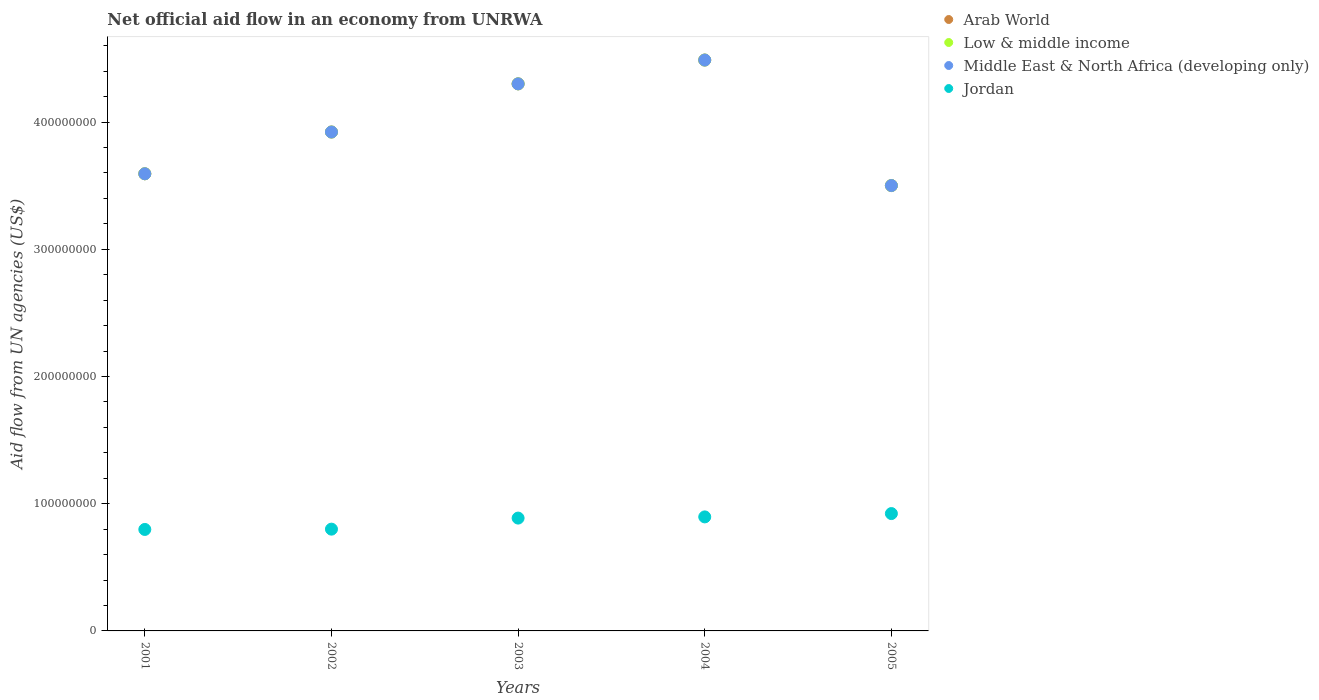What is the net official aid flow in Low & middle income in 2005?
Offer a terse response. 3.50e+08. Across all years, what is the maximum net official aid flow in Arab World?
Offer a terse response. 4.49e+08. Across all years, what is the minimum net official aid flow in Low & middle income?
Keep it short and to the point. 3.50e+08. In which year was the net official aid flow in Middle East & North Africa (developing only) minimum?
Ensure brevity in your answer.  2005. What is the total net official aid flow in Jordan in the graph?
Keep it short and to the point. 4.30e+08. What is the difference between the net official aid flow in Middle East & North Africa (developing only) in 2004 and the net official aid flow in Jordan in 2003?
Your response must be concise. 3.60e+08. What is the average net official aid flow in Low & middle income per year?
Keep it short and to the point. 3.96e+08. In how many years, is the net official aid flow in Low & middle income greater than 440000000 US$?
Ensure brevity in your answer.  1. What is the ratio of the net official aid flow in Arab World in 2001 to that in 2005?
Offer a very short reply. 1.03. What is the difference between the highest and the second highest net official aid flow in Middle East & North Africa (developing only)?
Offer a terse response. 1.87e+07. What is the difference between the highest and the lowest net official aid flow in Jordan?
Ensure brevity in your answer.  1.25e+07. In how many years, is the net official aid flow in Middle East & North Africa (developing only) greater than the average net official aid flow in Middle East & North Africa (developing only) taken over all years?
Your answer should be very brief. 2. Does the net official aid flow in Middle East & North Africa (developing only) monotonically increase over the years?
Your answer should be very brief. No. How many years are there in the graph?
Offer a terse response. 5. What is the difference between two consecutive major ticks on the Y-axis?
Ensure brevity in your answer.  1.00e+08. Does the graph contain grids?
Provide a short and direct response. No. How many legend labels are there?
Ensure brevity in your answer.  4. How are the legend labels stacked?
Your answer should be very brief. Vertical. What is the title of the graph?
Keep it short and to the point. Net official aid flow in an economy from UNRWA. What is the label or title of the Y-axis?
Provide a short and direct response. Aid flow from UN agencies (US$). What is the Aid flow from UN agencies (US$) of Arab World in 2001?
Your answer should be very brief. 3.59e+08. What is the Aid flow from UN agencies (US$) of Low & middle income in 2001?
Give a very brief answer. 3.59e+08. What is the Aid flow from UN agencies (US$) in Middle East & North Africa (developing only) in 2001?
Give a very brief answer. 3.59e+08. What is the Aid flow from UN agencies (US$) in Jordan in 2001?
Ensure brevity in your answer.  7.98e+07. What is the Aid flow from UN agencies (US$) in Arab World in 2002?
Provide a succinct answer. 3.92e+08. What is the Aid flow from UN agencies (US$) in Low & middle income in 2002?
Ensure brevity in your answer.  3.92e+08. What is the Aid flow from UN agencies (US$) in Middle East & North Africa (developing only) in 2002?
Your response must be concise. 3.92e+08. What is the Aid flow from UN agencies (US$) of Jordan in 2002?
Offer a very short reply. 8.00e+07. What is the Aid flow from UN agencies (US$) of Arab World in 2003?
Make the answer very short. 4.30e+08. What is the Aid flow from UN agencies (US$) of Low & middle income in 2003?
Ensure brevity in your answer.  4.30e+08. What is the Aid flow from UN agencies (US$) of Middle East & North Africa (developing only) in 2003?
Make the answer very short. 4.30e+08. What is the Aid flow from UN agencies (US$) in Jordan in 2003?
Your response must be concise. 8.87e+07. What is the Aid flow from UN agencies (US$) in Arab World in 2004?
Your answer should be compact. 4.49e+08. What is the Aid flow from UN agencies (US$) in Low & middle income in 2004?
Offer a terse response. 4.49e+08. What is the Aid flow from UN agencies (US$) in Middle East & North Africa (developing only) in 2004?
Provide a short and direct response. 4.49e+08. What is the Aid flow from UN agencies (US$) in Jordan in 2004?
Offer a terse response. 8.96e+07. What is the Aid flow from UN agencies (US$) in Arab World in 2005?
Your answer should be very brief. 3.50e+08. What is the Aid flow from UN agencies (US$) of Low & middle income in 2005?
Offer a terse response. 3.50e+08. What is the Aid flow from UN agencies (US$) of Middle East & North Africa (developing only) in 2005?
Provide a succinct answer. 3.50e+08. What is the Aid flow from UN agencies (US$) in Jordan in 2005?
Provide a short and direct response. 9.22e+07. Across all years, what is the maximum Aid flow from UN agencies (US$) of Arab World?
Ensure brevity in your answer.  4.49e+08. Across all years, what is the maximum Aid flow from UN agencies (US$) of Low & middle income?
Ensure brevity in your answer.  4.49e+08. Across all years, what is the maximum Aid flow from UN agencies (US$) of Middle East & North Africa (developing only)?
Make the answer very short. 4.49e+08. Across all years, what is the maximum Aid flow from UN agencies (US$) of Jordan?
Offer a terse response. 9.22e+07. Across all years, what is the minimum Aid flow from UN agencies (US$) in Arab World?
Your response must be concise. 3.50e+08. Across all years, what is the minimum Aid flow from UN agencies (US$) of Low & middle income?
Provide a short and direct response. 3.50e+08. Across all years, what is the minimum Aid flow from UN agencies (US$) of Middle East & North Africa (developing only)?
Provide a short and direct response. 3.50e+08. Across all years, what is the minimum Aid flow from UN agencies (US$) in Jordan?
Offer a very short reply. 7.98e+07. What is the total Aid flow from UN agencies (US$) in Arab World in the graph?
Offer a very short reply. 1.98e+09. What is the total Aid flow from UN agencies (US$) in Low & middle income in the graph?
Provide a succinct answer. 1.98e+09. What is the total Aid flow from UN agencies (US$) in Middle East & North Africa (developing only) in the graph?
Your answer should be compact. 1.98e+09. What is the total Aid flow from UN agencies (US$) in Jordan in the graph?
Offer a very short reply. 4.30e+08. What is the difference between the Aid flow from UN agencies (US$) of Arab World in 2001 and that in 2002?
Your answer should be compact. -3.28e+07. What is the difference between the Aid flow from UN agencies (US$) in Low & middle income in 2001 and that in 2002?
Make the answer very short. -3.28e+07. What is the difference between the Aid flow from UN agencies (US$) of Middle East & North Africa (developing only) in 2001 and that in 2002?
Your answer should be compact. -3.28e+07. What is the difference between the Aid flow from UN agencies (US$) in Jordan in 2001 and that in 2002?
Give a very brief answer. -2.40e+05. What is the difference between the Aid flow from UN agencies (US$) in Arab World in 2001 and that in 2003?
Offer a very short reply. -7.07e+07. What is the difference between the Aid flow from UN agencies (US$) in Low & middle income in 2001 and that in 2003?
Your response must be concise. -7.07e+07. What is the difference between the Aid flow from UN agencies (US$) of Middle East & North Africa (developing only) in 2001 and that in 2003?
Offer a terse response. -7.07e+07. What is the difference between the Aid flow from UN agencies (US$) of Jordan in 2001 and that in 2003?
Your response must be concise. -8.93e+06. What is the difference between the Aid flow from UN agencies (US$) in Arab World in 2001 and that in 2004?
Offer a very short reply. -8.94e+07. What is the difference between the Aid flow from UN agencies (US$) of Low & middle income in 2001 and that in 2004?
Provide a short and direct response. -8.94e+07. What is the difference between the Aid flow from UN agencies (US$) in Middle East & North Africa (developing only) in 2001 and that in 2004?
Provide a succinct answer. -8.94e+07. What is the difference between the Aid flow from UN agencies (US$) of Jordan in 2001 and that in 2004?
Your answer should be compact. -9.87e+06. What is the difference between the Aid flow from UN agencies (US$) of Arab World in 2001 and that in 2005?
Provide a short and direct response. 9.26e+06. What is the difference between the Aid flow from UN agencies (US$) of Low & middle income in 2001 and that in 2005?
Offer a very short reply. 9.26e+06. What is the difference between the Aid flow from UN agencies (US$) of Middle East & North Africa (developing only) in 2001 and that in 2005?
Your answer should be very brief. 9.26e+06. What is the difference between the Aid flow from UN agencies (US$) of Jordan in 2001 and that in 2005?
Your answer should be compact. -1.25e+07. What is the difference between the Aid flow from UN agencies (US$) of Arab World in 2002 and that in 2003?
Ensure brevity in your answer.  -3.79e+07. What is the difference between the Aid flow from UN agencies (US$) of Low & middle income in 2002 and that in 2003?
Provide a succinct answer. -3.79e+07. What is the difference between the Aid flow from UN agencies (US$) in Middle East & North Africa (developing only) in 2002 and that in 2003?
Your answer should be very brief. -3.79e+07. What is the difference between the Aid flow from UN agencies (US$) in Jordan in 2002 and that in 2003?
Your response must be concise. -8.69e+06. What is the difference between the Aid flow from UN agencies (US$) of Arab World in 2002 and that in 2004?
Keep it short and to the point. -5.66e+07. What is the difference between the Aid flow from UN agencies (US$) of Low & middle income in 2002 and that in 2004?
Offer a terse response. -5.66e+07. What is the difference between the Aid flow from UN agencies (US$) in Middle East & North Africa (developing only) in 2002 and that in 2004?
Provide a succinct answer. -5.66e+07. What is the difference between the Aid flow from UN agencies (US$) in Jordan in 2002 and that in 2004?
Your answer should be very brief. -9.63e+06. What is the difference between the Aid flow from UN agencies (US$) in Arab World in 2002 and that in 2005?
Keep it short and to the point. 4.21e+07. What is the difference between the Aid flow from UN agencies (US$) in Low & middle income in 2002 and that in 2005?
Ensure brevity in your answer.  4.21e+07. What is the difference between the Aid flow from UN agencies (US$) of Middle East & North Africa (developing only) in 2002 and that in 2005?
Your answer should be very brief. 4.21e+07. What is the difference between the Aid flow from UN agencies (US$) in Jordan in 2002 and that in 2005?
Your answer should be compact. -1.22e+07. What is the difference between the Aid flow from UN agencies (US$) in Arab World in 2003 and that in 2004?
Provide a succinct answer. -1.87e+07. What is the difference between the Aid flow from UN agencies (US$) in Low & middle income in 2003 and that in 2004?
Make the answer very short. -1.87e+07. What is the difference between the Aid flow from UN agencies (US$) in Middle East & North Africa (developing only) in 2003 and that in 2004?
Ensure brevity in your answer.  -1.87e+07. What is the difference between the Aid flow from UN agencies (US$) of Jordan in 2003 and that in 2004?
Keep it short and to the point. -9.40e+05. What is the difference between the Aid flow from UN agencies (US$) of Arab World in 2003 and that in 2005?
Ensure brevity in your answer.  8.00e+07. What is the difference between the Aid flow from UN agencies (US$) in Low & middle income in 2003 and that in 2005?
Offer a terse response. 8.00e+07. What is the difference between the Aid flow from UN agencies (US$) in Middle East & North Africa (developing only) in 2003 and that in 2005?
Your answer should be compact. 8.00e+07. What is the difference between the Aid flow from UN agencies (US$) of Jordan in 2003 and that in 2005?
Give a very brief answer. -3.55e+06. What is the difference between the Aid flow from UN agencies (US$) in Arab World in 2004 and that in 2005?
Keep it short and to the point. 9.87e+07. What is the difference between the Aid flow from UN agencies (US$) in Low & middle income in 2004 and that in 2005?
Your answer should be compact. 9.87e+07. What is the difference between the Aid flow from UN agencies (US$) in Middle East & North Africa (developing only) in 2004 and that in 2005?
Offer a terse response. 9.87e+07. What is the difference between the Aid flow from UN agencies (US$) of Jordan in 2004 and that in 2005?
Your answer should be very brief. -2.61e+06. What is the difference between the Aid flow from UN agencies (US$) of Arab World in 2001 and the Aid flow from UN agencies (US$) of Low & middle income in 2002?
Your response must be concise. -3.28e+07. What is the difference between the Aid flow from UN agencies (US$) of Arab World in 2001 and the Aid flow from UN agencies (US$) of Middle East & North Africa (developing only) in 2002?
Your answer should be very brief. -3.28e+07. What is the difference between the Aid flow from UN agencies (US$) in Arab World in 2001 and the Aid flow from UN agencies (US$) in Jordan in 2002?
Ensure brevity in your answer.  2.79e+08. What is the difference between the Aid flow from UN agencies (US$) in Low & middle income in 2001 and the Aid flow from UN agencies (US$) in Middle East & North Africa (developing only) in 2002?
Give a very brief answer. -3.28e+07. What is the difference between the Aid flow from UN agencies (US$) of Low & middle income in 2001 and the Aid flow from UN agencies (US$) of Jordan in 2002?
Keep it short and to the point. 2.79e+08. What is the difference between the Aid flow from UN agencies (US$) of Middle East & North Africa (developing only) in 2001 and the Aid flow from UN agencies (US$) of Jordan in 2002?
Your answer should be compact. 2.79e+08. What is the difference between the Aid flow from UN agencies (US$) in Arab World in 2001 and the Aid flow from UN agencies (US$) in Low & middle income in 2003?
Provide a short and direct response. -7.07e+07. What is the difference between the Aid flow from UN agencies (US$) of Arab World in 2001 and the Aid flow from UN agencies (US$) of Middle East & North Africa (developing only) in 2003?
Make the answer very short. -7.07e+07. What is the difference between the Aid flow from UN agencies (US$) of Arab World in 2001 and the Aid flow from UN agencies (US$) of Jordan in 2003?
Make the answer very short. 2.71e+08. What is the difference between the Aid flow from UN agencies (US$) of Low & middle income in 2001 and the Aid flow from UN agencies (US$) of Middle East & North Africa (developing only) in 2003?
Give a very brief answer. -7.07e+07. What is the difference between the Aid flow from UN agencies (US$) in Low & middle income in 2001 and the Aid flow from UN agencies (US$) in Jordan in 2003?
Provide a short and direct response. 2.71e+08. What is the difference between the Aid flow from UN agencies (US$) in Middle East & North Africa (developing only) in 2001 and the Aid flow from UN agencies (US$) in Jordan in 2003?
Your answer should be very brief. 2.71e+08. What is the difference between the Aid flow from UN agencies (US$) in Arab World in 2001 and the Aid flow from UN agencies (US$) in Low & middle income in 2004?
Your answer should be compact. -8.94e+07. What is the difference between the Aid flow from UN agencies (US$) in Arab World in 2001 and the Aid flow from UN agencies (US$) in Middle East & North Africa (developing only) in 2004?
Provide a succinct answer. -8.94e+07. What is the difference between the Aid flow from UN agencies (US$) of Arab World in 2001 and the Aid flow from UN agencies (US$) of Jordan in 2004?
Make the answer very short. 2.70e+08. What is the difference between the Aid flow from UN agencies (US$) of Low & middle income in 2001 and the Aid flow from UN agencies (US$) of Middle East & North Africa (developing only) in 2004?
Offer a terse response. -8.94e+07. What is the difference between the Aid flow from UN agencies (US$) of Low & middle income in 2001 and the Aid flow from UN agencies (US$) of Jordan in 2004?
Your response must be concise. 2.70e+08. What is the difference between the Aid flow from UN agencies (US$) of Middle East & North Africa (developing only) in 2001 and the Aid flow from UN agencies (US$) of Jordan in 2004?
Give a very brief answer. 2.70e+08. What is the difference between the Aid flow from UN agencies (US$) in Arab World in 2001 and the Aid flow from UN agencies (US$) in Low & middle income in 2005?
Keep it short and to the point. 9.26e+06. What is the difference between the Aid flow from UN agencies (US$) of Arab World in 2001 and the Aid flow from UN agencies (US$) of Middle East & North Africa (developing only) in 2005?
Your response must be concise. 9.26e+06. What is the difference between the Aid flow from UN agencies (US$) of Arab World in 2001 and the Aid flow from UN agencies (US$) of Jordan in 2005?
Ensure brevity in your answer.  2.67e+08. What is the difference between the Aid flow from UN agencies (US$) of Low & middle income in 2001 and the Aid flow from UN agencies (US$) of Middle East & North Africa (developing only) in 2005?
Provide a short and direct response. 9.26e+06. What is the difference between the Aid flow from UN agencies (US$) in Low & middle income in 2001 and the Aid flow from UN agencies (US$) in Jordan in 2005?
Give a very brief answer. 2.67e+08. What is the difference between the Aid flow from UN agencies (US$) in Middle East & North Africa (developing only) in 2001 and the Aid flow from UN agencies (US$) in Jordan in 2005?
Your response must be concise. 2.67e+08. What is the difference between the Aid flow from UN agencies (US$) in Arab World in 2002 and the Aid flow from UN agencies (US$) in Low & middle income in 2003?
Give a very brief answer. -3.79e+07. What is the difference between the Aid flow from UN agencies (US$) of Arab World in 2002 and the Aid flow from UN agencies (US$) of Middle East & North Africa (developing only) in 2003?
Your answer should be very brief. -3.79e+07. What is the difference between the Aid flow from UN agencies (US$) of Arab World in 2002 and the Aid flow from UN agencies (US$) of Jordan in 2003?
Give a very brief answer. 3.04e+08. What is the difference between the Aid flow from UN agencies (US$) of Low & middle income in 2002 and the Aid flow from UN agencies (US$) of Middle East & North Africa (developing only) in 2003?
Provide a short and direct response. -3.79e+07. What is the difference between the Aid flow from UN agencies (US$) in Low & middle income in 2002 and the Aid flow from UN agencies (US$) in Jordan in 2003?
Offer a very short reply. 3.04e+08. What is the difference between the Aid flow from UN agencies (US$) in Middle East & North Africa (developing only) in 2002 and the Aid flow from UN agencies (US$) in Jordan in 2003?
Offer a terse response. 3.04e+08. What is the difference between the Aid flow from UN agencies (US$) in Arab World in 2002 and the Aid flow from UN agencies (US$) in Low & middle income in 2004?
Make the answer very short. -5.66e+07. What is the difference between the Aid flow from UN agencies (US$) in Arab World in 2002 and the Aid flow from UN agencies (US$) in Middle East & North Africa (developing only) in 2004?
Offer a very short reply. -5.66e+07. What is the difference between the Aid flow from UN agencies (US$) of Arab World in 2002 and the Aid flow from UN agencies (US$) of Jordan in 2004?
Provide a succinct answer. 3.03e+08. What is the difference between the Aid flow from UN agencies (US$) in Low & middle income in 2002 and the Aid flow from UN agencies (US$) in Middle East & North Africa (developing only) in 2004?
Your response must be concise. -5.66e+07. What is the difference between the Aid flow from UN agencies (US$) in Low & middle income in 2002 and the Aid flow from UN agencies (US$) in Jordan in 2004?
Your answer should be very brief. 3.03e+08. What is the difference between the Aid flow from UN agencies (US$) in Middle East & North Africa (developing only) in 2002 and the Aid flow from UN agencies (US$) in Jordan in 2004?
Provide a short and direct response. 3.03e+08. What is the difference between the Aid flow from UN agencies (US$) of Arab World in 2002 and the Aid flow from UN agencies (US$) of Low & middle income in 2005?
Ensure brevity in your answer.  4.21e+07. What is the difference between the Aid flow from UN agencies (US$) of Arab World in 2002 and the Aid flow from UN agencies (US$) of Middle East & North Africa (developing only) in 2005?
Ensure brevity in your answer.  4.21e+07. What is the difference between the Aid flow from UN agencies (US$) in Arab World in 2002 and the Aid flow from UN agencies (US$) in Jordan in 2005?
Offer a very short reply. 3.00e+08. What is the difference between the Aid flow from UN agencies (US$) of Low & middle income in 2002 and the Aid flow from UN agencies (US$) of Middle East & North Africa (developing only) in 2005?
Your response must be concise. 4.21e+07. What is the difference between the Aid flow from UN agencies (US$) in Low & middle income in 2002 and the Aid flow from UN agencies (US$) in Jordan in 2005?
Provide a short and direct response. 3.00e+08. What is the difference between the Aid flow from UN agencies (US$) of Middle East & North Africa (developing only) in 2002 and the Aid flow from UN agencies (US$) of Jordan in 2005?
Your response must be concise. 3.00e+08. What is the difference between the Aid flow from UN agencies (US$) of Arab World in 2003 and the Aid flow from UN agencies (US$) of Low & middle income in 2004?
Ensure brevity in your answer.  -1.87e+07. What is the difference between the Aid flow from UN agencies (US$) of Arab World in 2003 and the Aid flow from UN agencies (US$) of Middle East & North Africa (developing only) in 2004?
Your answer should be compact. -1.87e+07. What is the difference between the Aid flow from UN agencies (US$) of Arab World in 2003 and the Aid flow from UN agencies (US$) of Jordan in 2004?
Give a very brief answer. 3.40e+08. What is the difference between the Aid flow from UN agencies (US$) of Low & middle income in 2003 and the Aid flow from UN agencies (US$) of Middle East & North Africa (developing only) in 2004?
Provide a short and direct response. -1.87e+07. What is the difference between the Aid flow from UN agencies (US$) of Low & middle income in 2003 and the Aid flow from UN agencies (US$) of Jordan in 2004?
Give a very brief answer. 3.40e+08. What is the difference between the Aid flow from UN agencies (US$) in Middle East & North Africa (developing only) in 2003 and the Aid flow from UN agencies (US$) in Jordan in 2004?
Your response must be concise. 3.40e+08. What is the difference between the Aid flow from UN agencies (US$) in Arab World in 2003 and the Aid flow from UN agencies (US$) in Low & middle income in 2005?
Ensure brevity in your answer.  8.00e+07. What is the difference between the Aid flow from UN agencies (US$) in Arab World in 2003 and the Aid flow from UN agencies (US$) in Middle East & North Africa (developing only) in 2005?
Give a very brief answer. 8.00e+07. What is the difference between the Aid flow from UN agencies (US$) in Arab World in 2003 and the Aid flow from UN agencies (US$) in Jordan in 2005?
Keep it short and to the point. 3.38e+08. What is the difference between the Aid flow from UN agencies (US$) of Low & middle income in 2003 and the Aid flow from UN agencies (US$) of Middle East & North Africa (developing only) in 2005?
Your answer should be very brief. 8.00e+07. What is the difference between the Aid flow from UN agencies (US$) of Low & middle income in 2003 and the Aid flow from UN agencies (US$) of Jordan in 2005?
Your answer should be very brief. 3.38e+08. What is the difference between the Aid flow from UN agencies (US$) of Middle East & North Africa (developing only) in 2003 and the Aid flow from UN agencies (US$) of Jordan in 2005?
Your answer should be very brief. 3.38e+08. What is the difference between the Aid flow from UN agencies (US$) in Arab World in 2004 and the Aid flow from UN agencies (US$) in Low & middle income in 2005?
Offer a very short reply. 9.87e+07. What is the difference between the Aid flow from UN agencies (US$) in Arab World in 2004 and the Aid flow from UN agencies (US$) in Middle East & North Africa (developing only) in 2005?
Keep it short and to the point. 9.87e+07. What is the difference between the Aid flow from UN agencies (US$) in Arab World in 2004 and the Aid flow from UN agencies (US$) in Jordan in 2005?
Give a very brief answer. 3.57e+08. What is the difference between the Aid flow from UN agencies (US$) of Low & middle income in 2004 and the Aid flow from UN agencies (US$) of Middle East & North Africa (developing only) in 2005?
Keep it short and to the point. 9.87e+07. What is the difference between the Aid flow from UN agencies (US$) of Low & middle income in 2004 and the Aid flow from UN agencies (US$) of Jordan in 2005?
Offer a terse response. 3.57e+08. What is the difference between the Aid flow from UN agencies (US$) in Middle East & North Africa (developing only) in 2004 and the Aid flow from UN agencies (US$) in Jordan in 2005?
Offer a terse response. 3.57e+08. What is the average Aid flow from UN agencies (US$) of Arab World per year?
Your response must be concise. 3.96e+08. What is the average Aid flow from UN agencies (US$) of Low & middle income per year?
Offer a very short reply. 3.96e+08. What is the average Aid flow from UN agencies (US$) of Middle East & North Africa (developing only) per year?
Your response must be concise. 3.96e+08. What is the average Aid flow from UN agencies (US$) of Jordan per year?
Give a very brief answer. 8.61e+07. In the year 2001, what is the difference between the Aid flow from UN agencies (US$) of Arab World and Aid flow from UN agencies (US$) of Middle East & North Africa (developing only)?
Offer a very short reply. 0. In the year 2001, what is the difference between the Aid flow from UN agencies (US$) of Arab World and Aid flow from UN agencies (US$) of Jordan?
Make the answer very short. 2.80e+08. In the year 2001, what is the difference between the Aid flow from UN agencies (US$) of Low & middle income and Aid flow from UN agencies (US$) of Jordan?
Keep it short and to the point. 2.80e+08. In the year 2001, what is the difference between the Aid flow from UN agencies (US$) of Middle East & North Africa (developing only) and Aid flow from UN agencies (US$) of Jordan?
Provide a succinct answer. 2.80e+08. In the year 2002, what is the difference between the Aid flow from UN agencies (US$) in Arab World and Aid flow from UN agencies (US$) in Middle East & North Africa (developing only)?
Your response must be concise. 0. In the year 2002, what is the difference between the Aid flow from UN agencies (US$) of Arab World and Aid flow from UN agencies (US$) of Jordan?
Your answer should be very brief. 3.12e+08. In the year 2002, what is the difference between the Aid flow from UN agencies (US$) in Low & middle income and Aid flow from UN agencies (US$) in Jordan?
Your answer should be very brief. 3.12e+08. In the year 2002, what is the difference between the Aid flow from UN agencies (US$) in Middle East & North Africa (developing only) and Aid flow from UN agencies (US$) in Jordan?
Ensure brevity in your answer.  3.12e+08. In the year 2003, what is the difference between the Aid flow from UN agencies (US$) in Arab World and Aid flow from UN agencies (US$) in Jordan?
Offer a very short reply. 3.41e+08. In the year 2003, what is the difference between the Aid flow from UN agencies (US$) in Low & middle income and Aid flow from UN agencies (US$) in Middle East & North Africa (developing only)?
Your answer should be very brief. 0. In the year 2003, what is the difference between the Aid flow from UN agencies (US$) of Low & middle income and Aid flow from UN agencies (US$) of Jordan?
Make the answer very short. 3.41e+08. In the year 2003, what is the difference between the Aid flow from UN agencies (US$) of Middle East & North Africa (developing only) and Aid flow from UN agencies (US$) of Jordan?
Give a very brief answer. 3.41e+08. In the year 2004, what is the difference between the Aid flow from UN agencies (US$) of Arab World and Aid flow from UN agencies (US$) of Low & middle income?
Provide a succinct answer. 0. In the year 2004, what is the difference between the Aid flow from UN agencies (US$) of Arab World and Aid flow from UN agencies (US$) of Middle East & North Africa (developing only)?
Ensure brevity in your answer.  0. In the year 2004, what is the difference between the Aid flow from UN agencies (US$) in Arab World and Aid flow from UN agencies (US$) in Jordan?
Your response must be concise. 3.59e+08. In the year 2004, what is the difference between the Aid flow from UN agencies (US$) in Low & middle income and Aid flow from UN agencies (US$) in Jordan?
Ensure brevity in your answer.  3.59e+08. In the year 2004, what is the difference between the Aid flow from UN agencies (US$) in Middle East & North Africa (developing only) and Aid flow from UN agencies (US$) in Jordan?
Provide a succinct answer. 3.59e+08. In the year 2005, what is the difference between the Aid flow from UN agencies (US$) of Arab World and Aid flow from UN agencies (US$) of Middle East & North Africa (developing only)?
Your answer should be compact. 0. In the year 2005, what is the difference between the Aid flow from UN agencies (US$) in Arab World and Aid flow from UN agencies (US$) in Jordan?
Offer a very short reply. 2.58e+08. In the year 2005, what is the difference between the Aid flow from UN agencies (US$) in Low & middle income and Aid flow from UN agencies (US$) in Jordan?
Give a very brief answer. 2.58e+08. In the year 2005, what is the difference between the Aid flow from UN agencies (US$) in Middle East & North Africa (developing only) and Aid flow from UN agencies (US$) in Jordan?
Make the answer very short. 2.58e+08. What is the ratio of the Aid flow from UN agencies (US$) of Arab World in 2001 to that in 2002?
Offer a very short reply. 0.92. What is the ratio of the Aid flow from UN agencies (US$) in Low & middle income in 2001 to that in 2002?
Make the answer very short. 0.92. What is the ratio of the Aid flow from UN agencies (US$) of Middle East & North Africa (developing only) in 2001 to that in 2002?
Offer a very short reply. 0.92. What is the ratio of the Aid flow from UN agencies (US$) in Jordan in 2001 to that in 2002?
Your answer should be compact. 1. What is the ratio of the Aid flow from UN agencies (US$) in Arab World in 2001 to that in 2003?
Your answer should be very brief. 0.84. What is the ratio of the Aid flow from UN agencies (US$) in Low & middle income in 2001 to that in 2003?
Offer a very short reply. 0.84. What is the ratio of the Aid flow from UN agencies (US$) of Middle East & North Africa (developing only) in 2001 to that in 2003?
Your response must be concise. 0.84. What is the ratio of the Aid flow from UN agencies (US$) of Jordan in 2001 to that in 2003?
Provide a short and direct response. 0.9. What is the ratio of the Aid flow from UN agencies (US$) in Arab World in 2001 to that in 2004?
Offer a terse response. 0.8. What is the ratio of the Aid flow from UN agencies (US$) in Low & middle income in 2001 to that in 2004?
Make the answer very short. 0.8. What is the ratio of the Aid flow from UN agencies (US$) in Middle East & North Africa (developing only) in 2001 to that in 2004?
Make the answer very short. 0.8. What is the ratio of the Aid flow from UN agencies (US$) of Jordan in 2001 to that in 2004?
Keep it short and to the point. 0.89. What is the ratio of the Aid flow from UN agencies (US$) of Arab World in 2001 to that in 2005?
Make the answer very short. 1.03. What is the ratio of the Aid flow from UN agencies (US$) in Low & middle income in 2001 to that in 2005?
Offer a terse response. 1.03. What is the ratio of the Aid flow from UN agencies (US$) of Middle East & North Africa (developing only) in 2001 to that in 2005?
Make the answer very short. 1.03. What is the ratio of the Aid flow from UN agencies (US$) in Jordan in 2001 to that in 2005?
Your response must be concise. 0.86. What is the ratio of the Aid flow from UN agencies (US$) of Arab World in 2002 to that in 2003?
Offer a very short reply. 0.91. What is the ratio of the Aid flow from UN agencies (US$) of Low & middle income in 2002 to that in 2003?
Keep it short and to the point. 0.91. What is the ratio of the Aid flow from UN agencies (US$) in Middle East & North Africa (developing only) in 2002 to that in 2003?
Your answer should be very brief. 0.91. What is the ratio of the Aid flow from UN agencies (US$) in Jordan in 2002 to that in 2003?
Offer a very short reply. 0.9. What is the ratio of the Aid flow from UN agencies (US$) of Arab World in 2002 to that in 2004?
Your response must be concise. 0.87. What is the ratio of the Aid flow from UN agencies (US$) of Low & middle income in 2002 to that in 2004?
Give a very brief answer. 0.87. What is the ratio of the Aid flow from UN agencies (US$) in Middle East & North Africa (developing only) in 2002 to that in 2004?
Provide a succinct answer. 0.87. What is the ratio of the Aid flow from UN agencies (US$) in Jordan in 2002 to that in 2004?
Provide a short and direct response. 0.89. What is the ratio of the Aid flow from UN agencies (US$) of Arab World in 2002 to that in 2005?
Your response must be concise. 1.12. What is the ratio of the Aid flow from UN agencies (US$) in Low & middle income in 2002 to that in 2005?
Keep it short and to the point. 1.12. What is the ratio of the Aid flow from UN agencies (US$) of Middle East & North Africa (developing only) in 2002 to that in 2005?
Provide a succinct answer. 1.12. What is the ratio of the Aid flow from UN agencies (US$) of Jordan in 2002 to that in 2005?
Provide a succinct answer. 0.87. What is the ratio of the Aid flow from UN agencies (US$) of Arab World in 2003 to that in 2004?
Keep it short and to the point. 0.96. What is the ratio of the Aid flow from UN agencies (US$) in Jordan in 2003 to that in 2004?
Make the answer very short. 0.99. What is the ratio of the Aid flow from UN agencies (US$) in Arab World in 2003 to that in 2005?
Offer a very short reply. 1.23. What is the ratio of the Aid flow from UN agencies (US$) of Low & middle income in 2003 to that in 2005?
Make the answer very short. 1.23. What is the ratio of the Aid flow from UN agencies (US$) of Middle East & North Africa (developing only) in 2003 to that in 2005?
Your response must be concise. 1.23. What is the ratio of the Aid flow from UN agencies (US$) in Jordan in 2003 to that in 2005?
Provide a succinct answer. 0.96. What is the ratio of the Aid flow from UN agencies (US$) in Arab World in 2004 to that in 2005?
Provide a succinct answer. 1.28. What is the ratio of the Aid flow from UN agencies (US$) of Low & middle income in 2004 to that in 2005?
Provide a succinct answer. 1.28. What is the ratio of the Aid flow from UN agencies (US$) in Middle East & North Africa (developing only) in 2004 to that in 2005?
Offer a terse response. 1.28. What is the ratio of the Aid flow from UN agencies (US$) in Jordan in 2004 to that in 2005?
Provide a succinct answer. 0.97. What is the difference between the highest and the second highest Aid flow from UN agencies (US$) of Arab World?
Give a very brief answer. 1.87e+07. What is the difference between the highest and the second highest Aid flow from UN agencies (US$) in Low & middle income?
Provide a short and direct response. 1.87e+07. What is the difference between the highest and the second highest Aid flow from UN agencies (US$) in Middle East & North Africa (developing only)?
Offer a very short reply. 1.87e+07. What is the difference between the highest and the second highest Aid flow from UN agencies (US$) in Jordan?
Your response must be concise. 2.61e+06. What is the difference between the highest and the lowest Aid flow from UN agencies (US$) in Arab World?
Your answer should be compact. 9.87e+07. What is the difference between the highest and the lowest Aid flow from UN agencies (US$) in Low & middle income?
Provide a succinct answer. 9.87e+07. What is the difference between the highest and the lowest Aid flow from UN agencies (US$) of Middle East & North Africa (developing only)?
Provide a short and direct response. 9.87e+07. What is the difference between the highest and the lowest Aid flow from UN agencies (US$) of Jordan?
Provide a succinct answer. 1.25e+07. 